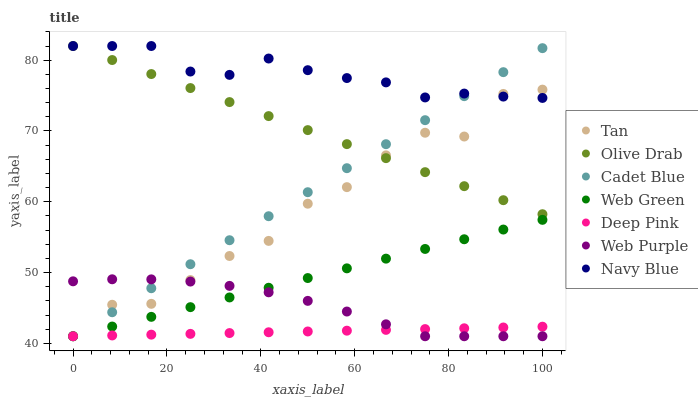Does Deep Pink have the minimum area under the curve?
Answer yes or no. Yes. Does Navy Blue have the maximum area under the curve?
Answer yes or no. Yes. Does Web Green have the minimum area under the curve?
Answer yes or no. No. Does Web Green have the maximum area under the curve?
Answer yes or no. No. Is Deep Pink the smoothest?
Answer yes or no. Yes. Is Tan the roughest?
Answer yes or no. Yes. Is Navy Blue the smoothest?
Answer yes or no. No. Is Navy Blue the roughest?
Answer yes or no. No. Does Cadet Blue have the lowest value?
Answer yes or no. Yes. Does Navy Blue have the lowest value?
Answer yes or no. No. Does Olive Drab have the highest value?
Answer yes or no. Yes. Does Web Green have the highest value?
Answer yes or no. No. Is Web Green less than Olive Drab?
Answer yes or no. Yes. Is Navy Blue greater than Web Purple?
Answer yes or no. Yes. Does Web Green intersect Tan?
Answer yes or no. Yes. Is Web Green less than Tan?
Answer yes or no. No. Is Web Green greater than Tan?
Answer yes or no. No. Does Web Green intersect Olive Drab?
Answer yes or no. No. 